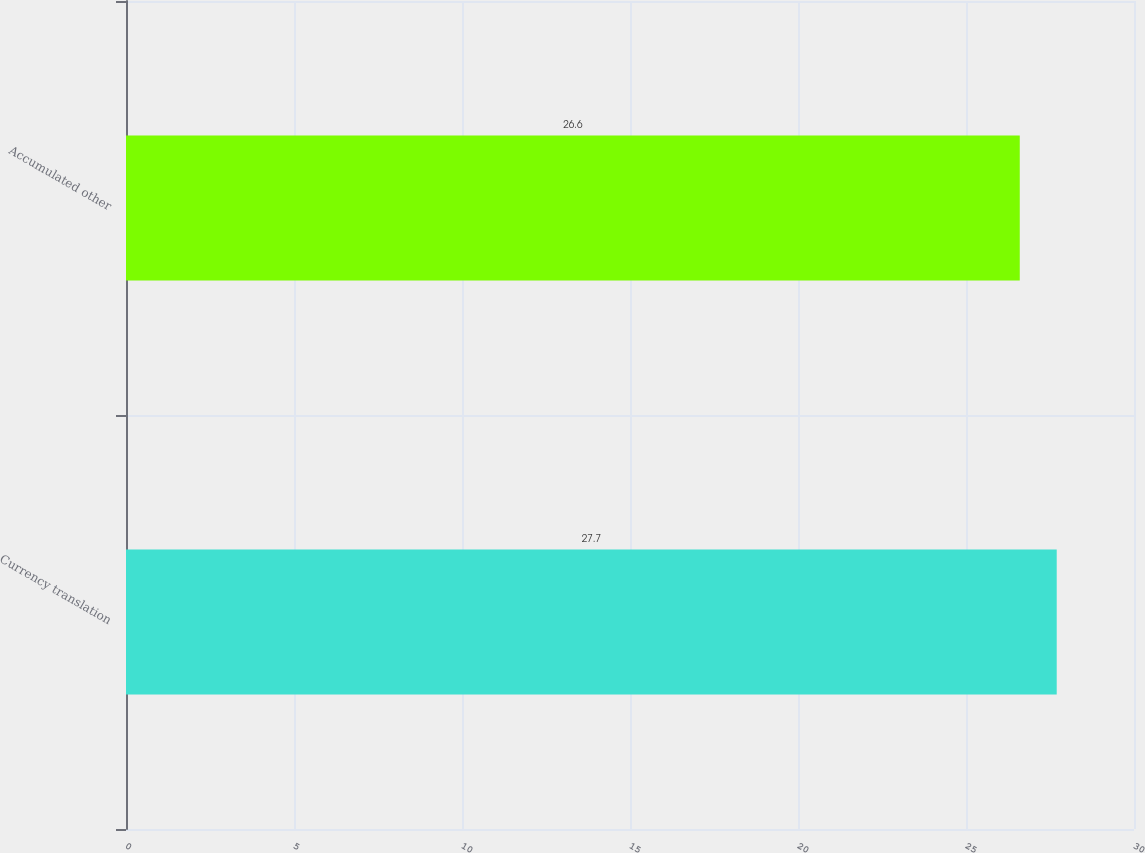Convert chart. <chart><loc_0><loc_0><loc_500><loc_500><bar_chart><fcel>Currency translation<fcel>Accumulated other<nl><fcel>27.7<fcel>26.6<nl></chart> 